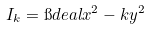Convert formula to latex. <formula><loc_0><loc_0><loc_500><loc_500>I _ { k } = \i d e a l { x ^ { 2 } - k y ^ { 2 } }</formula> 